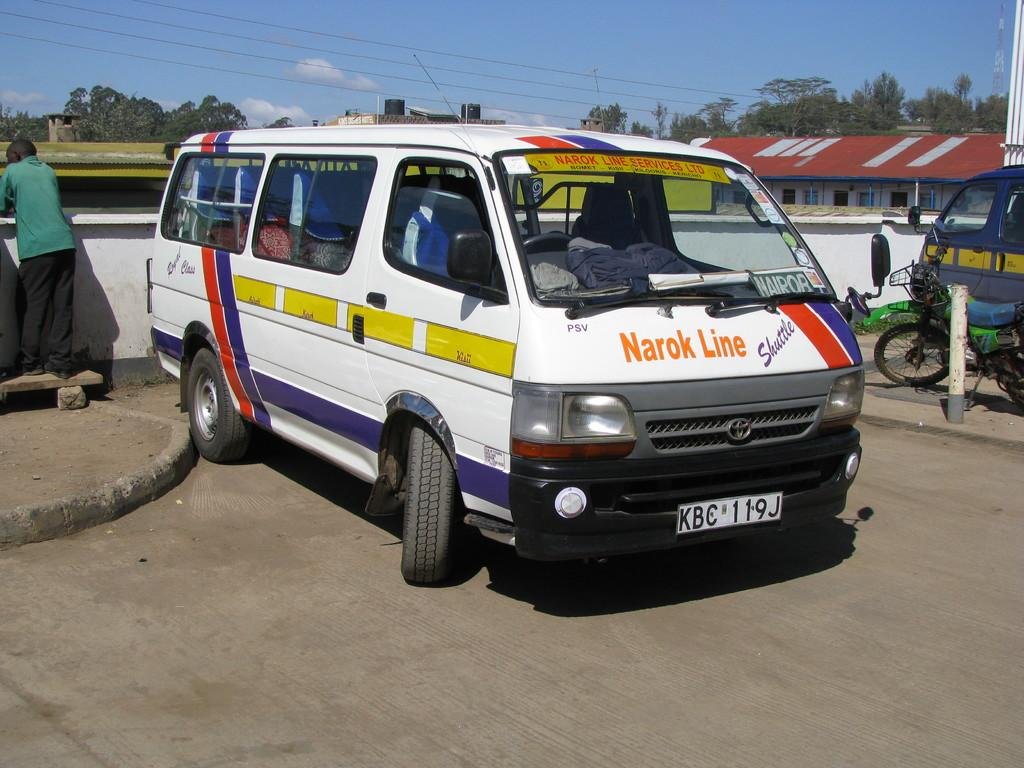<image>
Render a clear and concise summary of the photo. a parked white window van by narok line 